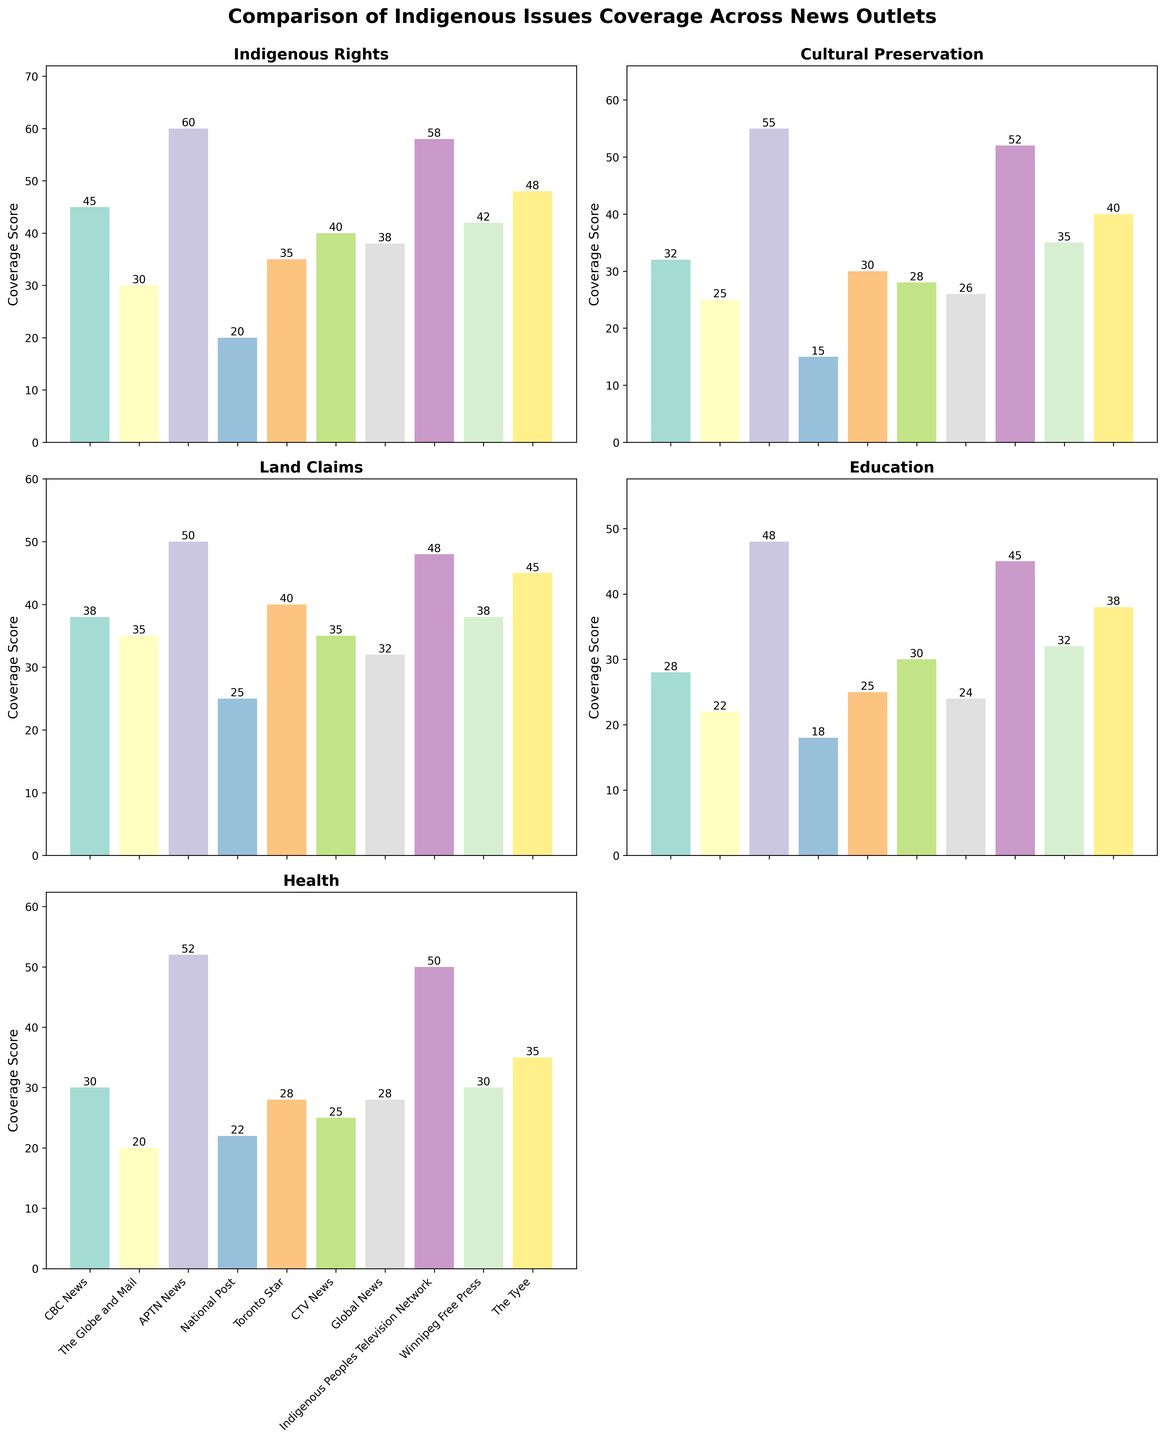Which news outlet has the highest coverage on Indigenous rights? The bar chart for "Indigenous Rights" shows that APTN News has the highest bar, indicating the highest coverage score.
Answer: APTN News What is the difference in coverage of Indigenous health issues between CBC News and National Post? The bar chart for "Health" shows CBC News with a value of 30 and National Post with a value of 22. The difference is calculated by subtracting 22 from 30.
Answer: 8 Which news outlet has the lowest coverage score for cultural preservation? The bar chart for "Cultural Preservation" shows that National Post has the lowest bar, indicating the lowest coverage score.
Answer: National Post How many news outlets have a coverage score on Land Claims that is 40 or higher? The bar chart for "Land Claims" shows that APTN News, Indigenous Peoples Television Network, and Toronto Star have coverage scores of 50, 48, and 40 respectively. Count these outlets.
Answer: Three Which category does the Toronto Star cover the most? By examining the height of the bars for Toronto Star across the categories, "Land Claims" has the highest bar.
Answer: Land Claims What is the average coverage score of The Tyee across all the categories? The scores for The Tyee are 48, 40, 45, 38, and 35. Sum these values to get 206 and divide by the number of categories, which is 5. The average is 206/5.
Answer: 41.2 Is the coverage of Education by CTV News higher or lower than by Winnipeg Free Press? The bar chart for "Education" shows that CTV News has a coverage score of 30, whereas Winnipeg Free Press has a score of 32. Thus, it is lower.
Answer: Lower Which category shows the most variation in coverage among different news outlets? Looking at the range of values (difference between highest and lowest values) for each category reveals that "Cultural Preservation" ranges from 55 to 15, showing the widest coverage variation.
Answer: Cultural Preservation Compare the coverage of Indigenous issues between CBC News and Global News. Which outlet has a higher total coverage score? Sum the coverage scores for CBC News across all categories (45+32+38+28+30 = 173) and Global News (38+26+32+24+28 = 148). CBC News has a higher total score.
Answer: CBC News Which news outlet has the closest score in covering Cultural Preservation and Health? Checking the bars for "Cultural Preservation" and "Health," APTN News with values of 55 and 52 respectively has the closest scores.
Answer: APTN News 